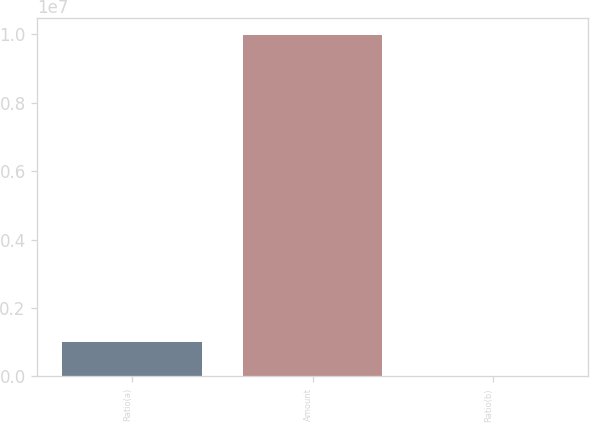<chart> <loc_0><loc_0><loc_500><loc_500><bar_chart><fcel>Ratio(a)<fcel>Amount<fcel>Ratio(b)<nl><fcel>997824<fcel>9.97816e+06<fcel>8.68<nl></chart> 